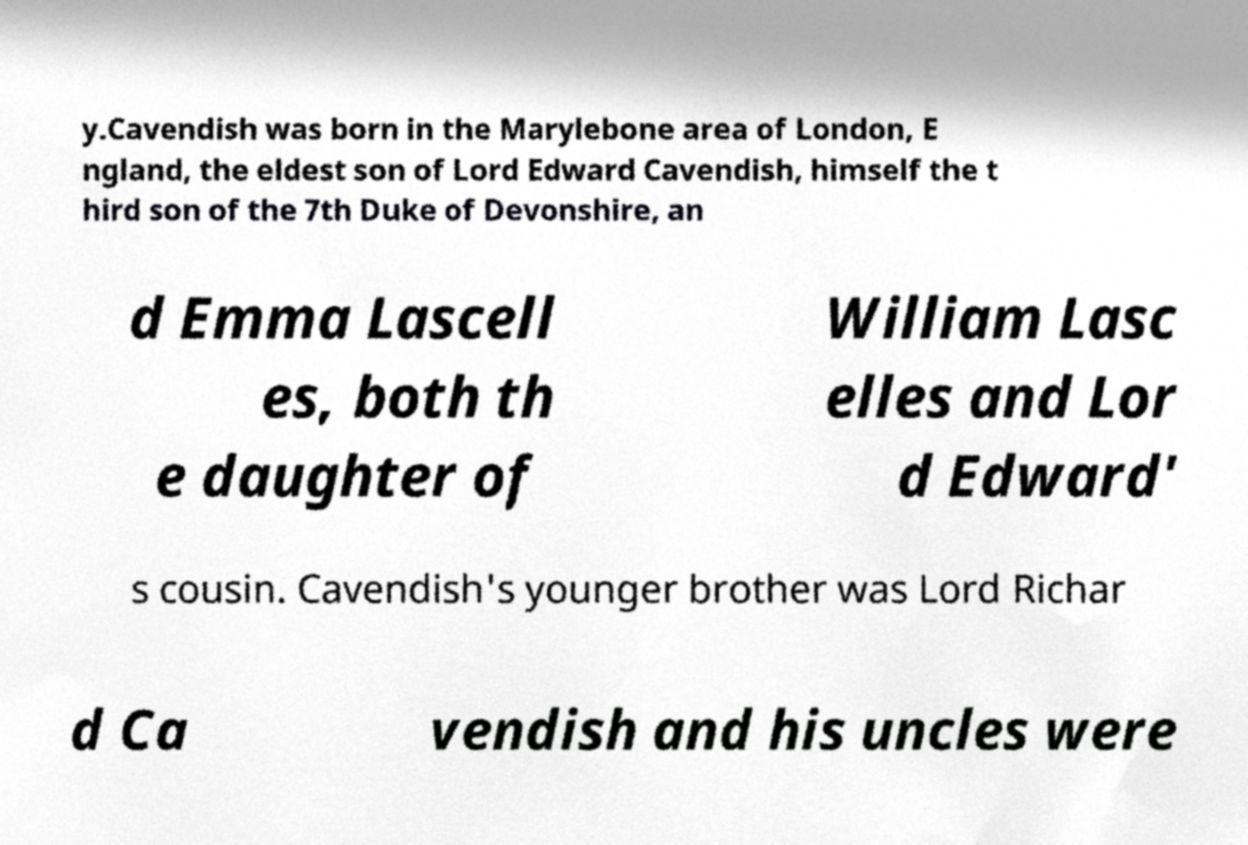Could you assist in decoding the text presented in this image and type it out clearly? y.Cavendish was born in the Marylebone area of London, E ngland, the eldest son of Lord Edward Cavendish, himself the t hird son of the 7th Duke of Devonshire, an d Emma Lascell es, both th e daughter of William Lasc elles and Lor d Edward' s cousin. Cavendish's younger brother was Lord Richar d Ca vendish and his uncles were 